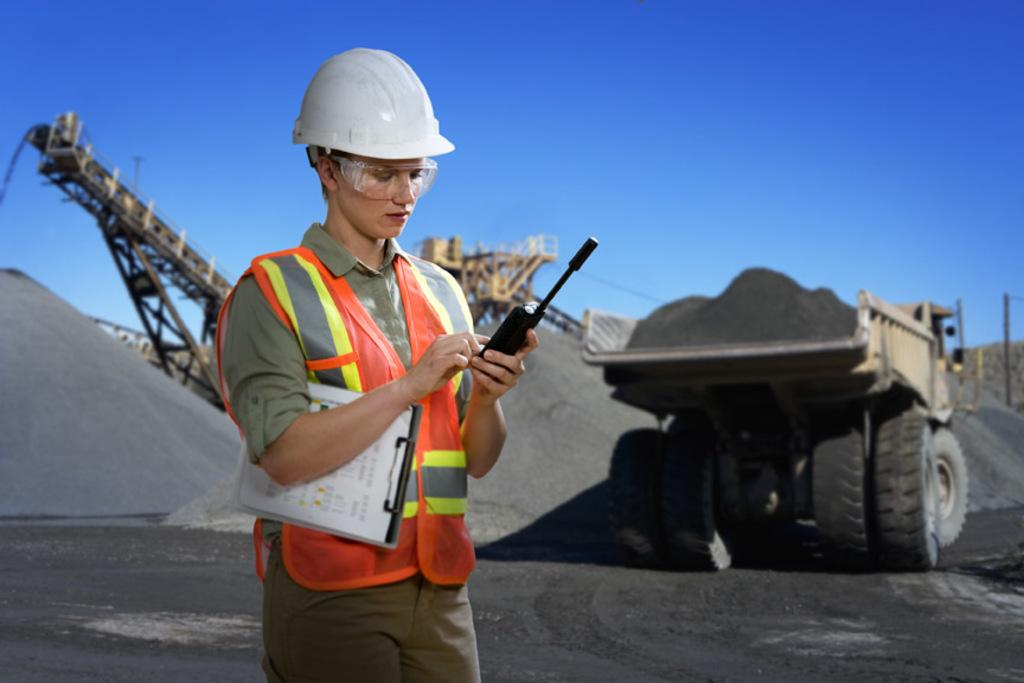What is the main subject of the image? There is a person in the image. What is the person wearing? The person is wearing a helmet. What is the person holding? The person is holding a microphone. What else can be seen in the image? There is a vehicle and sand on the floor in the image. How many kittens are playing with a pickle on the vehicle in the image? There are no kittens or pickles present in the image. Can you see a ladybug crawling on the person's helmet in the image? There is no ladybug visible on the person's helmet in the image. 